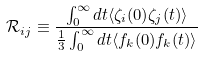<formula> <loc_0><loc_0><loc_500><loc_500>\mathcal { R } _ { i j } \equiv \frac { \int _ { 0 } ^ { \infty } d t \langle \zeta _ { i } ( 0 ) \zeta _ { j } ( t ) \rangle } { \frac { 1 } { 3 } \int _ { 0 } ^ { \infty } d t \langle f _ { k } ( 0 ) f _ { k } ( t ) \rangle }</formula> 